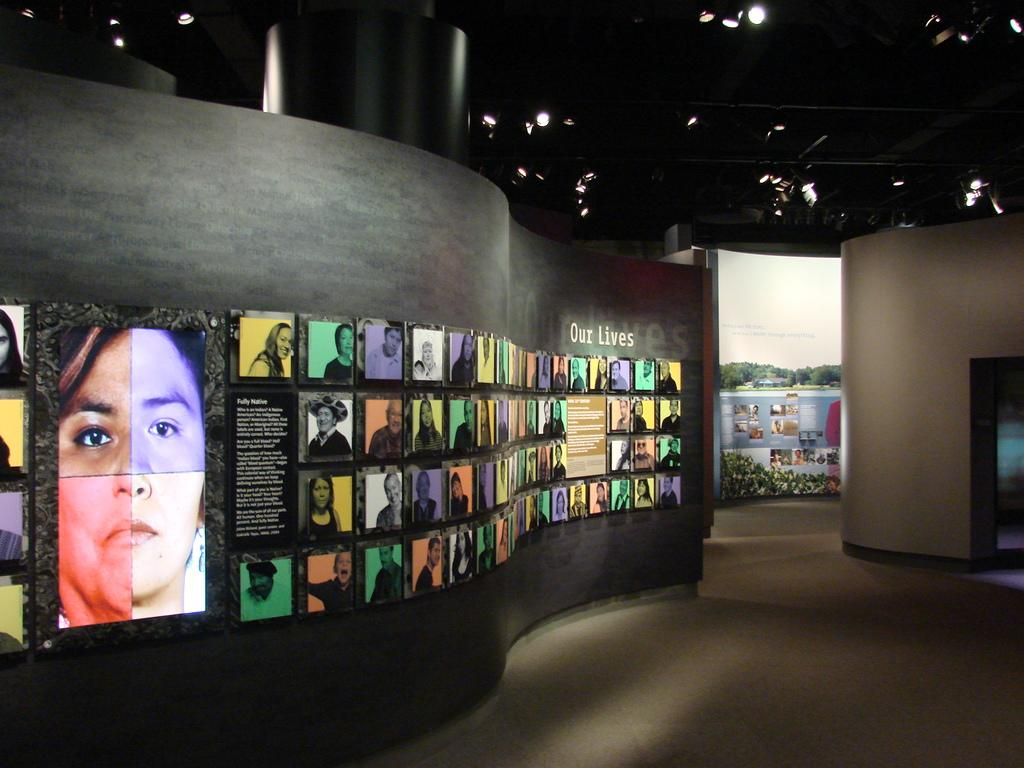What can be seen on the floor in the image? The floor is visible in the image, but there is no specific detail about the floor provided. What is hanging on the wall in the image? There are photo frames on the wall in the image. What type of illumination is present in the image? Lights are present in the image. What else can be seen in the image besides the floor, photo frames, and lights? There are objects in the image, but their specific details are not provided. How would you describe the overall lighting in the image? The background of the image is dark, which suggests that the lighting is dim or low. What type of committee is meeting in the image? There is no committee present in the image; it only shows a floor, photo frames, lights, and objects. Can you describe the liquid that is being poured in the image? There is no liquid being poured in the image; it only shows a floor, photo frames, lights, and objects. 